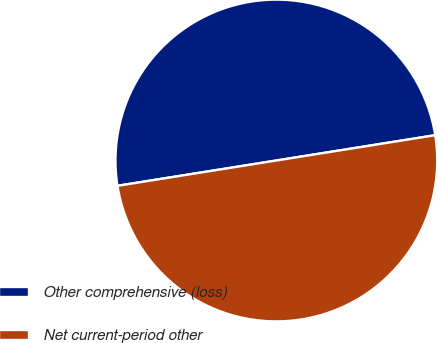Convert chart. <chart><loc_0><loc_0><loc_500><loc_500><pie_chart><fcel>Other comprehensive (loss)<fcel>Net current-period other<nl><fcel>50.0%<fcel>50.0%<nl></chart> 